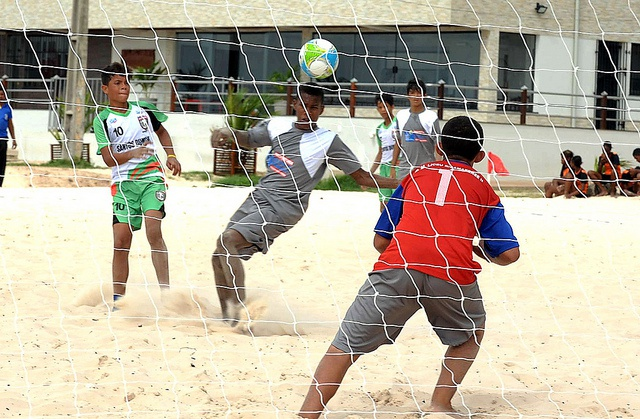Describe the objects in this image and their specific colors. I can see people in beige, red, gray, black, and brown tones, people in beige, gray, white, darkgray, and black tones, people in beige, white, gray, green, and black tones, people in beige, gray, white, darkgray, and black tones, and potted plant in beige, black, darkgreen, and gray tones in this image. 